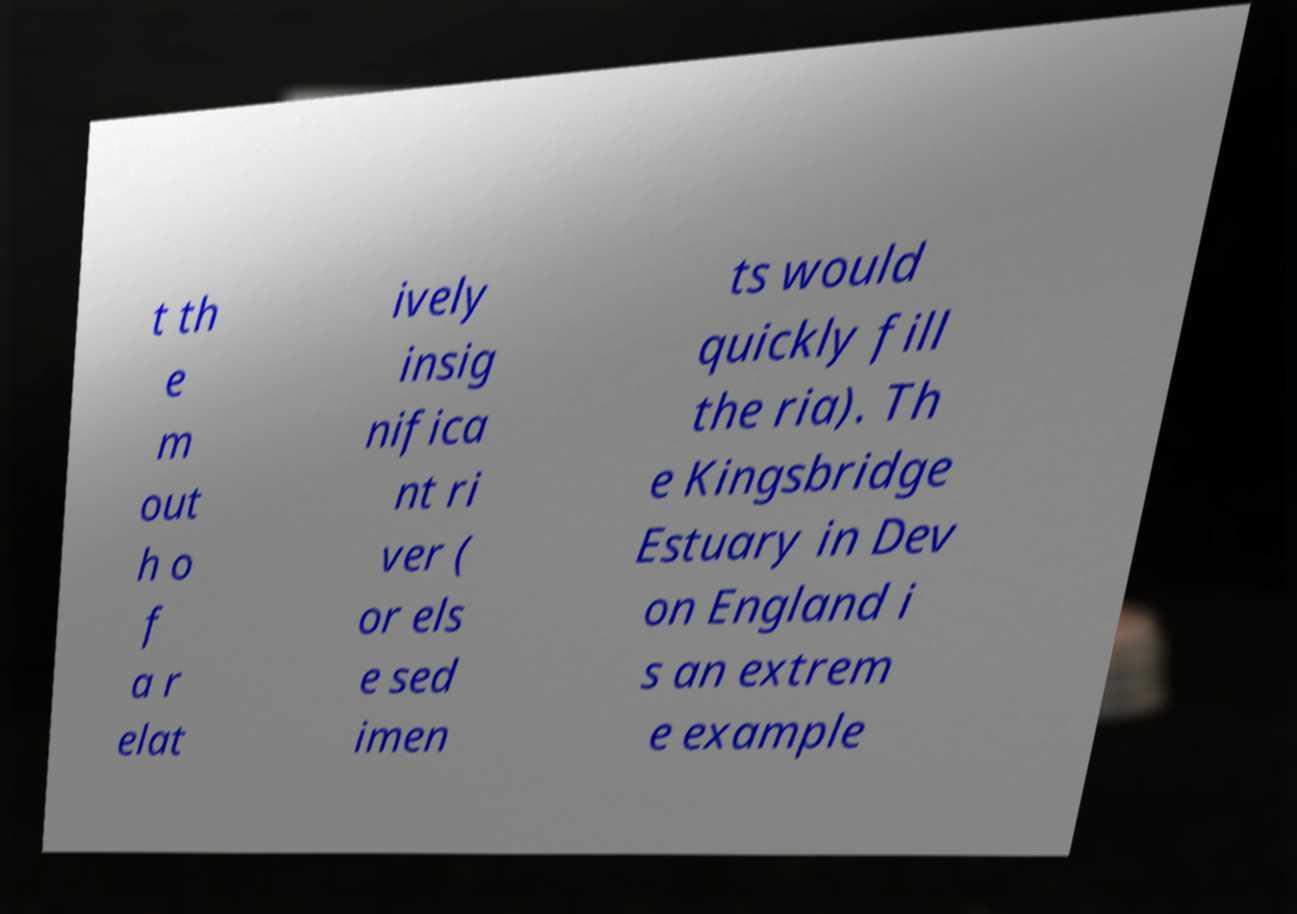What messages or text are displayed in this image? I need them in a readable, typed format. t th e m out h o f a r elat ively insig nifica nt ri ver ( or els e sed imen ts would quickly fill the ria). Th e Kingsbridge Estuary in Dev on England i s an extrem e example 